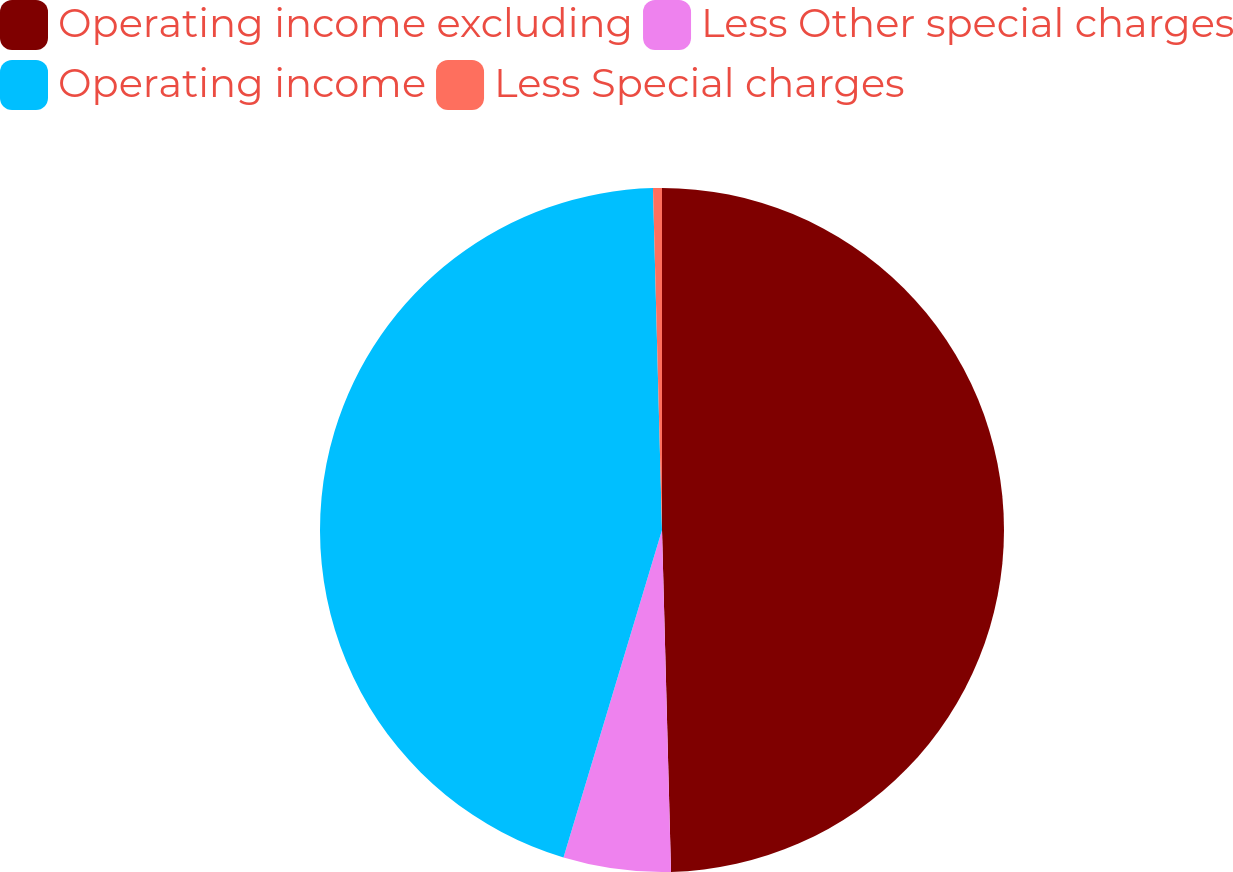<chart> <loc_0><loc_0><loc_500><loc_500><pie_chart><fcel>Operating income excluding<fcel>Less Other special charges<fcel>Operating income<fcel>Less Special charges<nl><fcel>49.58%<fcel>5.07%<fcel>44.93%<fcel>0.42%<nl></chart> 